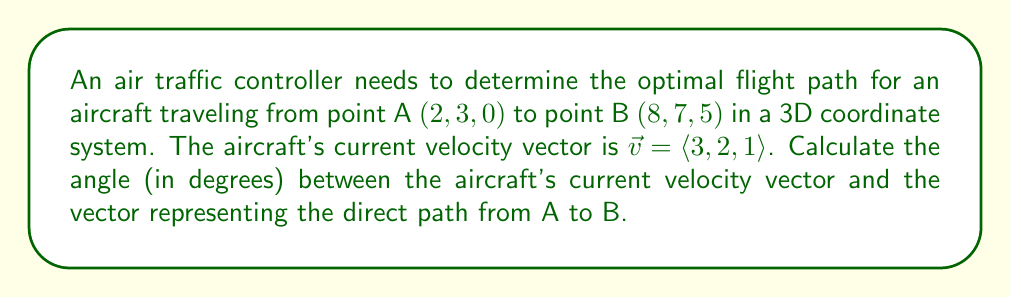Solve this math problem. To solve this problem, we'll follow these steps:

1. Find the vector $\vec{AB}$ representing the direct path from A to B.
2. Calculate the angle between $\vec{v}$ and $\vec{AB}$ using the dot product formula.

Step 1: Finding vector $\vec{AB}$
$$\vec{AB} = B - A = (8, 7, 5) - (2, 3, 0) = \langle 6, 4, 5 \rangle$$

Step 2: Calculating the angle
We'll use the formula: $\cos \theta = \frac{\vec{v} \cdot \vec{AB}}{|\vec{v}| |\vec{AB}|}$

First, let's calculate the dot product $\vec{v} \cdot \vec{AB}$:
$$\vec{v} \cdot \vec{AB} = (3)(6) + (2)(4) + (1)(5) = 18 + 8 + 5 = 31$$

Now, we need to find the magnitudes of $\vec{v}$ and $\vec{AB}$:
$$|\vec{v}| = \sqrt{3^2 + 2^2 + 1^2} = \sqrt{14}$$
$$|\vec{AB}| = \sqrt{6^2 + 4^2 + 5^2} = \sqrt{77}$$

Plugging these values into the formula:
$$\cos \theta = \frac{31}{\sqrt{14} \cdot \sqrt{77}}$$

To find $\theta$, we take the inverse cosine (arccos) of both sides:
$$\theta = \arccos\left(\frac{31}{\sqrt{14} \cdot \sqrt{77}}\right)$$

Using a calculator or computer, we can evaluate this expression:
$$\theta \approx 0.3838 \text{ radians}$$

Converting to degrees:
$$\theta \approx 0.3838 \cdot \frac{180°}{\pi} \approx 21.99°$$
Answer: The angle between the aircraft's current velocity vector and the vector representing the direct path from A to B is approximately $22.0°$. 